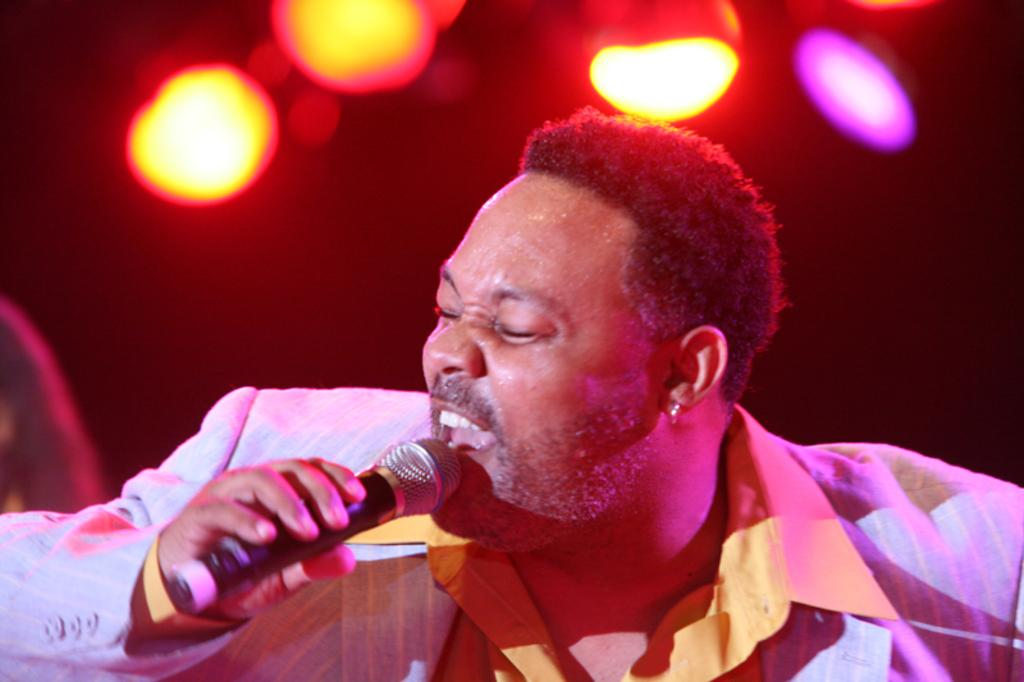What is the man in the picture doing? The man is singing on a microphone. What is the man wearing in the picture? The man is wearing a shirt and a suit. What can be seen at the top of the picture? There are decorative lights at the top of the picture. What type of soup is being served at the club in the image? There is no mention of soup or a club in the image; it features a man singing on a microphone. 